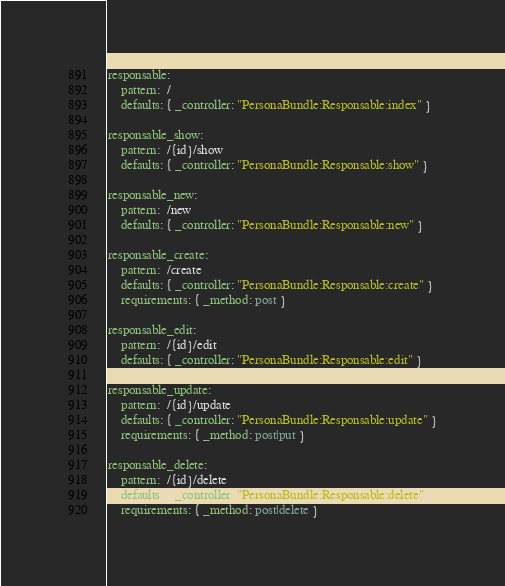<code> <loc_0><loc_0><loc_500><loc_500><_YAML_>responsable:
    pattern:  /
    defaults: { _controller: "PersonaBundle:Responsable:index" }

responsable_show:
    pattern:  /{id}/show
    defaults: { _controller: "PersonaBundle:Responsable:show" }

responsable_new:
    pattern:  /new
    defaults: { _controller: "PersonaBundle:Responsable:new" }

responsable_create:
    pattern:  /create
    defaults: { _controller: "PersonaBundle:Responsable:create" }
    requirements: { _method: post }

responsable_edit:
    pattern:  /{id}/edit
    defaults: { _controller: "PersonaBundle:Responsable:edit" }

responsable_update:
    pattern:  /{id}/update
    defaults: { _controller: "PersonaBundle:Responsable:update" }
    requirements: { _method: post|put }

responsable_delete:
    pattern:  /{id}/delete
    defaults: { _controller: "PersonaBundle:Responsable:delete" }
    requirements: { _method: post|delete }
</code> 